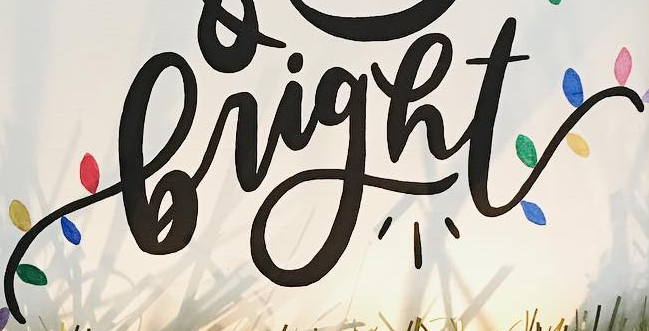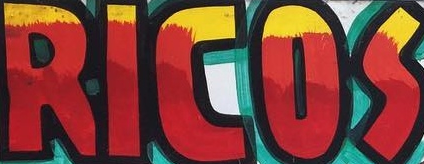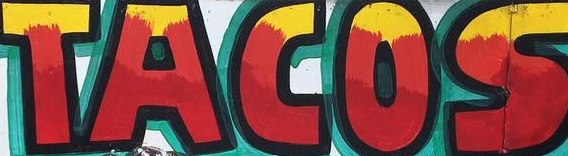What words can you see in these images in sequence, separated by a semicolon? bright; RICOS; TACOS 